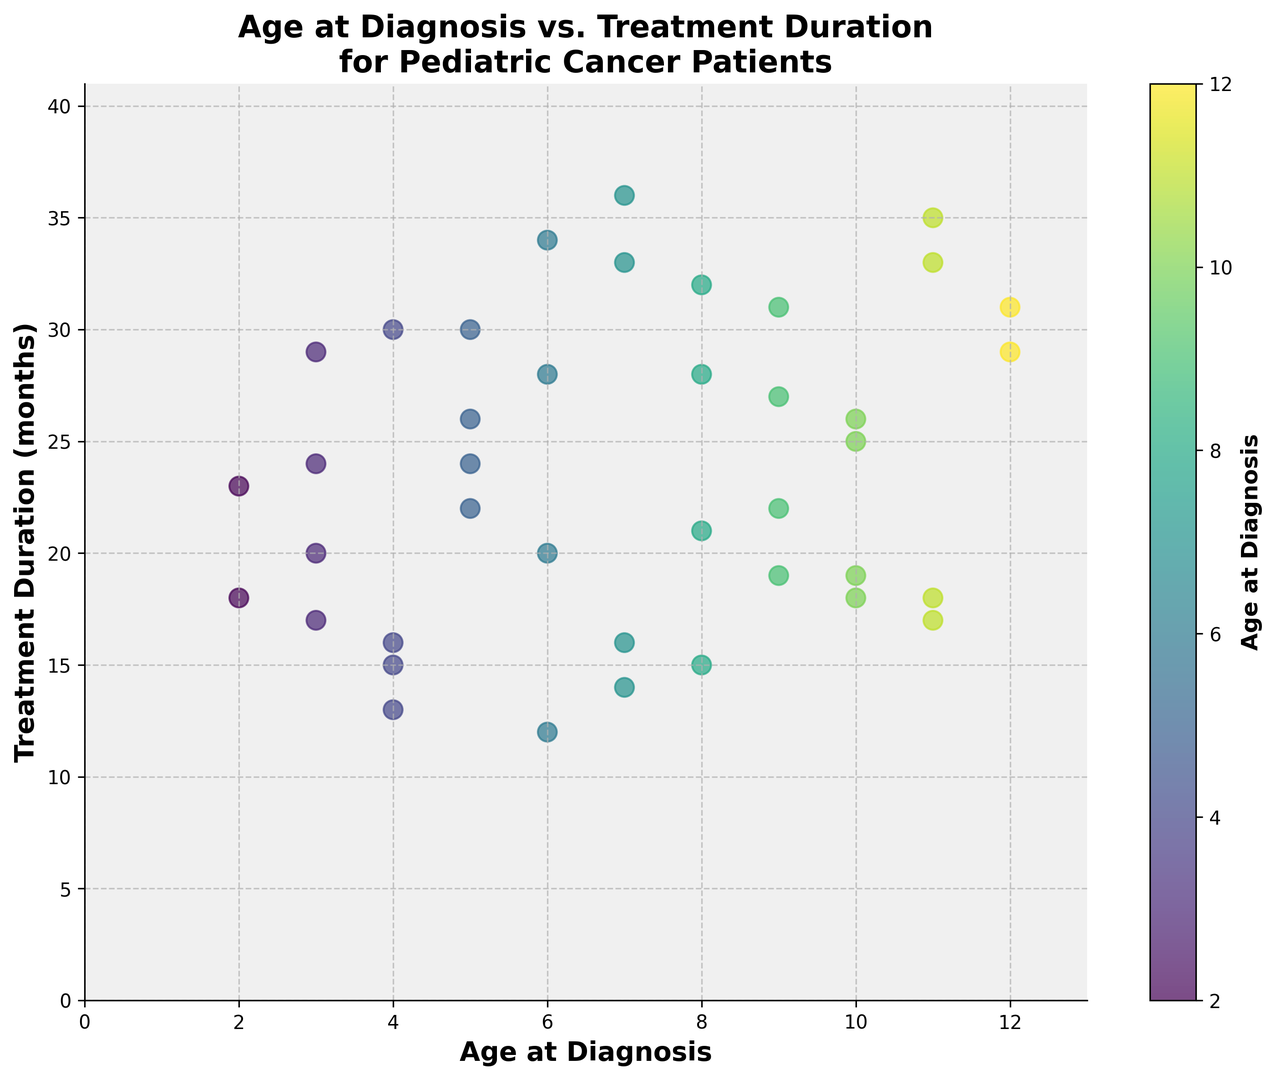What is the range of treatment duration for patients diagnosed at age 5? The treatment durations for patients diagnosed at age 5 are 30, 22, and 26 months. To find the range, we subtract the smallest value from the largest value: 30 - 22
Answer: 8 months Which age group has the widest range of treatment durations? For each age group, calculate the range by subtracting the minimum value from the maximum value. For example, age 7 has treatment durations of 36, 14, 33 months, giving a range of 36 - 14 = 22. Perform this for each age group and compare. Age 7 has the widest range (22 months)
Answer: Age 7 Does treatment duration increase, stay the same, or decrease as age at diagnosis increases? By observing the scatter plot trend, we see that the data points are more scattered with varying treatment durations for different ages, suggesting no clear trend of increase or decrease as age at diagnosis changes
Answer: No clear trend Which patient had the longest treatment duration, and what was their age at diagnosis? The longest treatment duration on the scatter plot is 36 months, which occurs at age 7. This can be found by looking at the highest data point on the y-axis and noting its corresponding x-axis value
Answer: Age 7 For patients aged 8, what is the average treatment duration? The treatment durations for patients aged 8 are 21, 32, 28, and 15 months. To find the average: (21 + 32 + 28 + 15) / 4 = 96 / 4 = 24
Answer: 24 months 